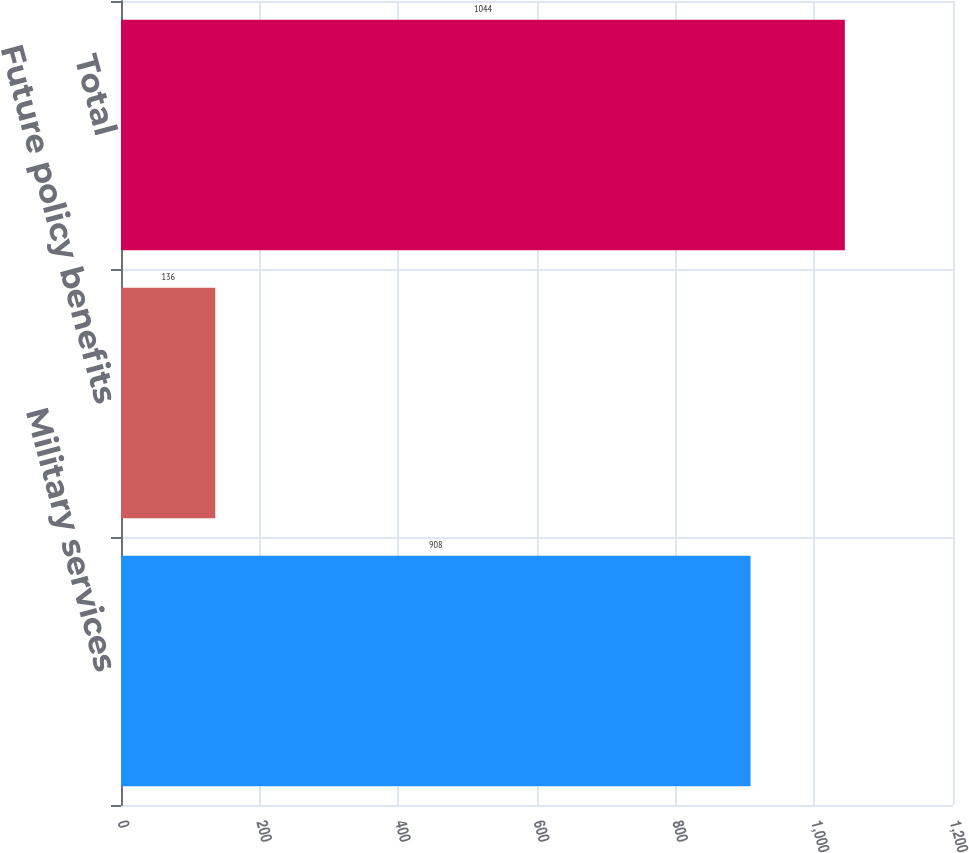Convert chart. <chart><loc_0><loc_0><loc_500><loc_500><bar_chart><fcel>Military services<fcel>Future policy benefits<fcel>Total<nl><fcel>908<fcel>136<fcel>1044<nl></chart> 